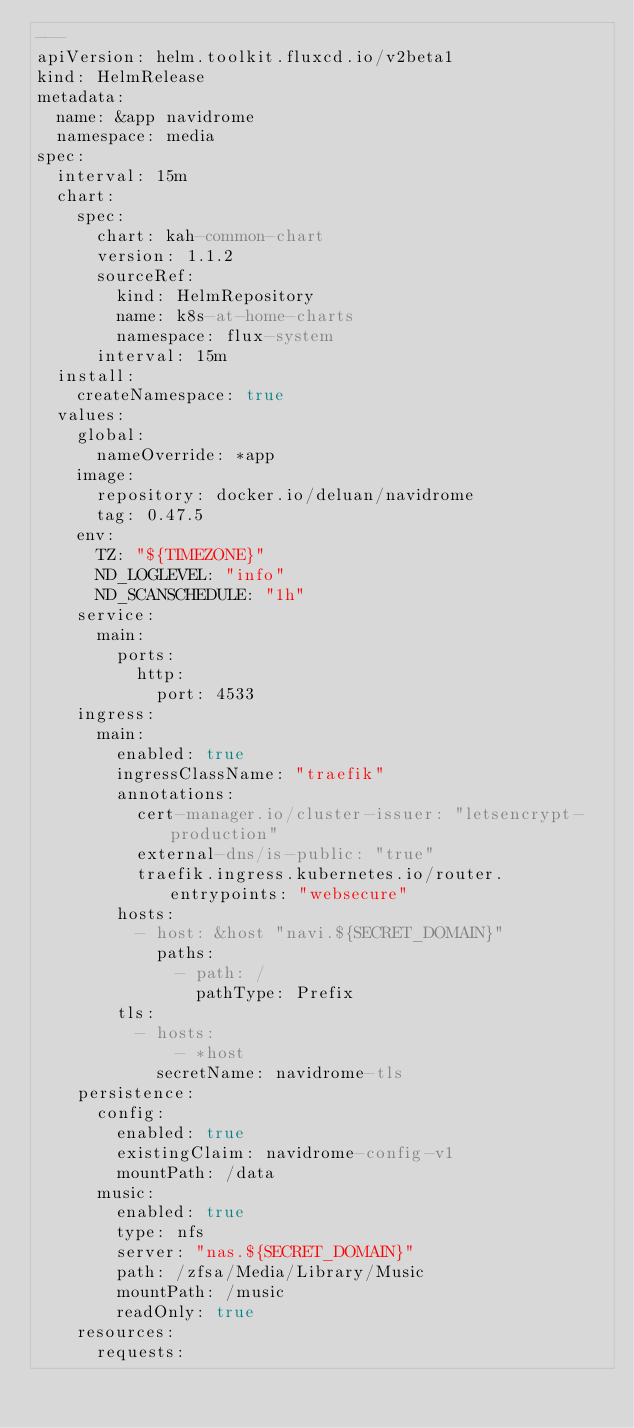<code> <loc_0><loc_0><loc_500><loc_500><_YAML_>---
apiVersion: helm.toolkit.fluxcd.io/v2beta1
kind: HelmRelease
metadata:
  name: &app navidrome
  namespace: media
spec:
  interval: 15m
  chart:
    spec:
      chart: kah-common-chart
      version: 1.1.2
      sourceRef:
        kind: HelmRepository
        name: k8s-at-home-charts
        namespace: flux-system
      interval: 15m
  install:
    createNamespace: true
  values:
    global:
      nameOverride: *app
    image:
      repository: docker.io/deluan/navidrome
      tag: 0.47.5
    env:
      TZ: "${TIMEZONE}"
      ND_LOGLEVEL: "info"
      ND_SCANSCHEDULE: "1h"
    service:
      main:
        ports:
          http:
            port: 4533
    ingress:
      main:
        enabled: true
        ingressClassName: "traefik"
        annotations:
          cert-manager.io/cluster-issuer: "letsencrypt-production"
          external-dns/is-public: "true"
          traefik.ingress.kubernetes.io/router.entrypoints: "websecure"
        hosts:
          - host: &host "navi.${SECRET_DOMAIN}"
            paths:
              - path: /
                pathType: Prefix
        tls:
          - hosts:
              - *host
            secretName: navidrome-tls
    persistence:
      config:
        enabled: true
        existingClaim: navidrome-config-v1
        mountPath: /data
      music:
        enabled: true
        type: nfs
        server: "nas.${SECRET_DOMAIN}"
        path: /zfsa/Media/Library/Music
        mountPath: /music
        readOnly: true
    resources:
      requests:</code> 